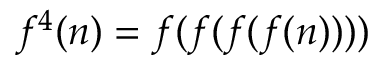Convert formula to latex. <formula><loc_0><loc_0><loc_500><loc_500>f ^ { 4 } ( n ) = f ( f ( f ( f ( n ) ) ) )</formula> 